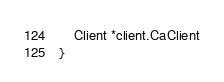Convert code to text. <code><loc_0><loc_0><loc_500><loc_500><_Go_>	Client *client.CaClient
}
</code> 